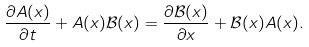<formula> <loc_0><loc_0><loc_500><loc_500>\frac { \partial A ( x ) } { \partial t } + A ( x ) \mathcal { B } ( x ) = \frac { \partial \mathcal { B } ( x ) } { \partial x } + \mathcal { B } ( x ) A ( x ) .</formula> 